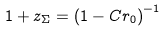Convert formula to latex. <formula><loc_0><loc_0><loc_500><loc_500>1 + z _ { \Sigma } = \left ( 1 - C r _ { 0 } \right ) ^ { - 1 }</formula> 